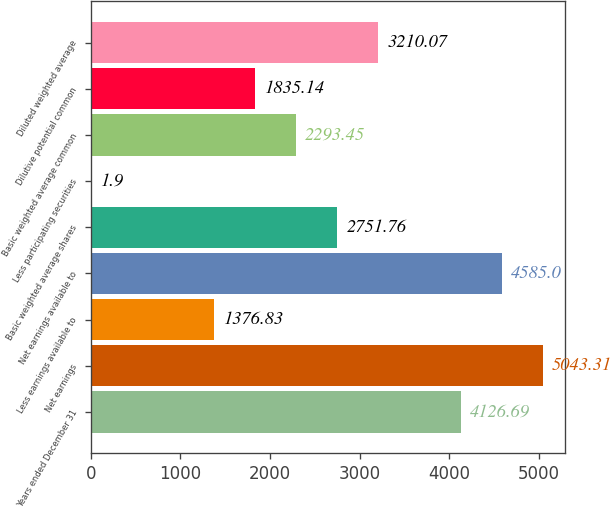<chart> <loc_0><loc_0><loc_500><loc_500><bar_chart><fcel>Years ended December 31<fcel>Net earnings<fcel>Less earnings available to<fcel>Net earnings available to<fcel>Basic weighted average shares<fcel>Less participating securities<fcel>Basic weighted average common<fcel>Dilutive potential common<fcel>Diluted weighted average<nl><fcel>4126.69<fcel>5043.31<fcel>1376.83<fcel>4585<fcel>2751.76<fcel>1.9<fcel>2293.45<fcel>1835.14<fcel>3210.07<nl></chart> 